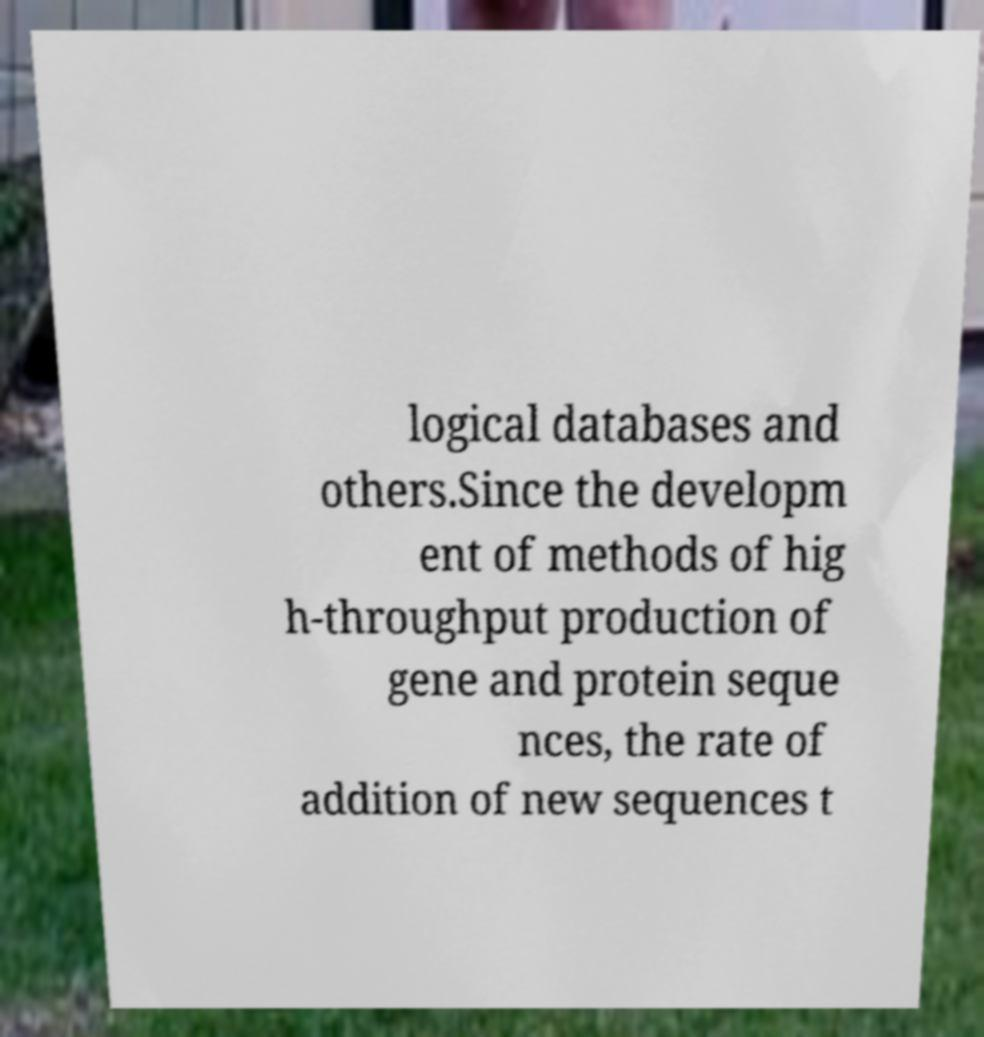Could you assist in decoding the text presented in this image and type it out clearly? logical databases and others.Since the developm ent of methods of hig h-throughput production of gene and protein seque nces, the rate of addition of new sequences t 